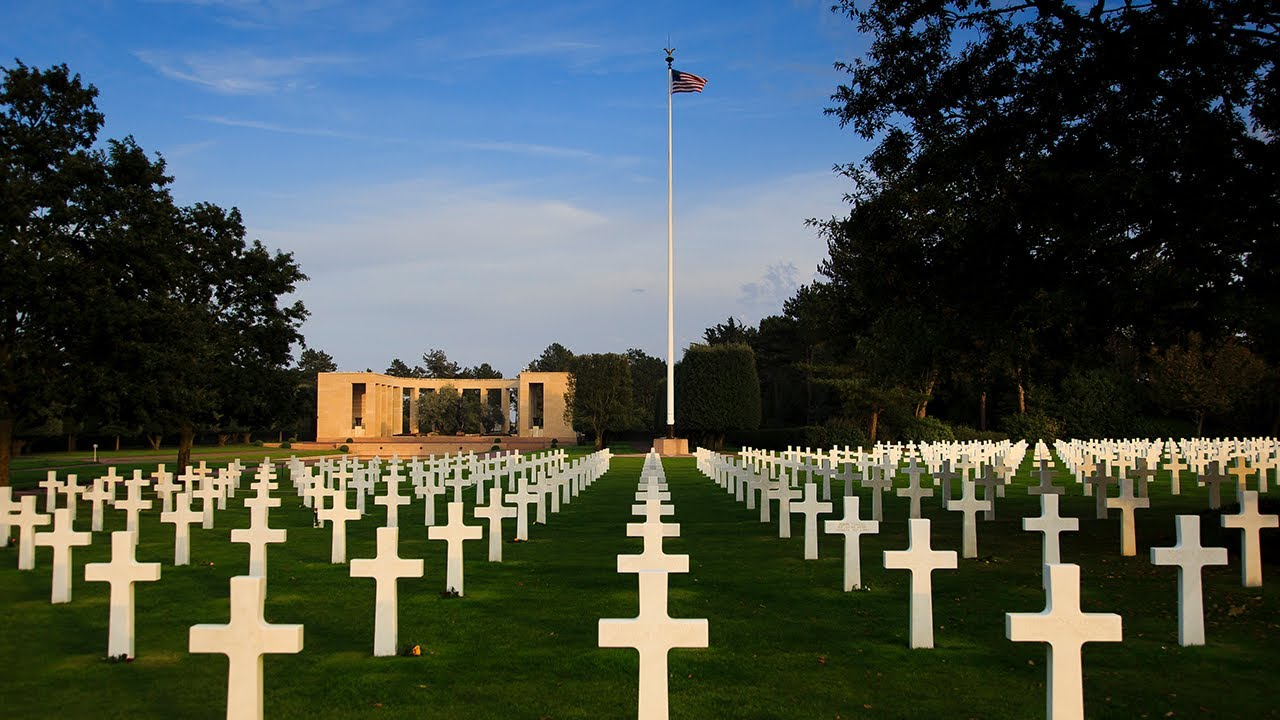What is the significance of the flag being at half-mast? The flag flying at half-mast is a traditional sign of mourning and respect. In this context, at the American Cemetery in Normandy, it serves as a homage to the soldiers who lost their lives during World War II, especially those who perished during the Normandy invasion. It symbolizes the nation's grief and the solemn remembrance of their sacrifice. 